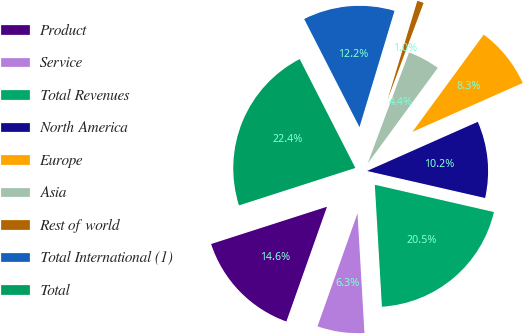Convert chart to OTSL. <chart><loc_0><loc_0><loc_500><loc_500><pie_chart><fcel>Product<fcel>Service<fcel>Total Revenues<fcel>North America<fcel>Europe<fcel>Asia<fcel>Rest of world<fcel>Total International (1)<fcel>Total<nl><fcel>14.63%<fcel>6.34%<fcel>20.49%<fcel>10.23%<fcel>8.29%<fcel>4.39%<fcel>1.02%<fcel>12.18%<fcel>22.43%<nl></chart> 